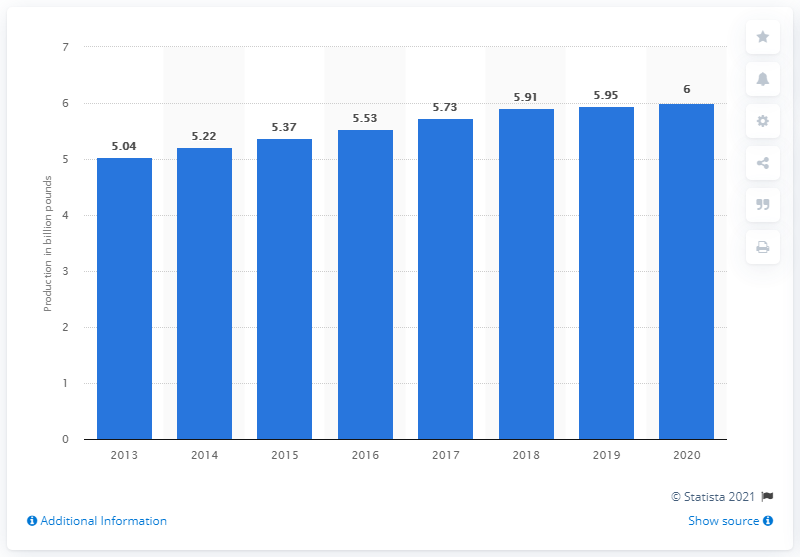Specify some key components in this picture. In 2016, a total of 5.53 metric tons of cheese were produced in the United States. 